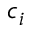<formula> <loc_0><loc_0><loc_500><loc_500>c _ { i }</formula> 